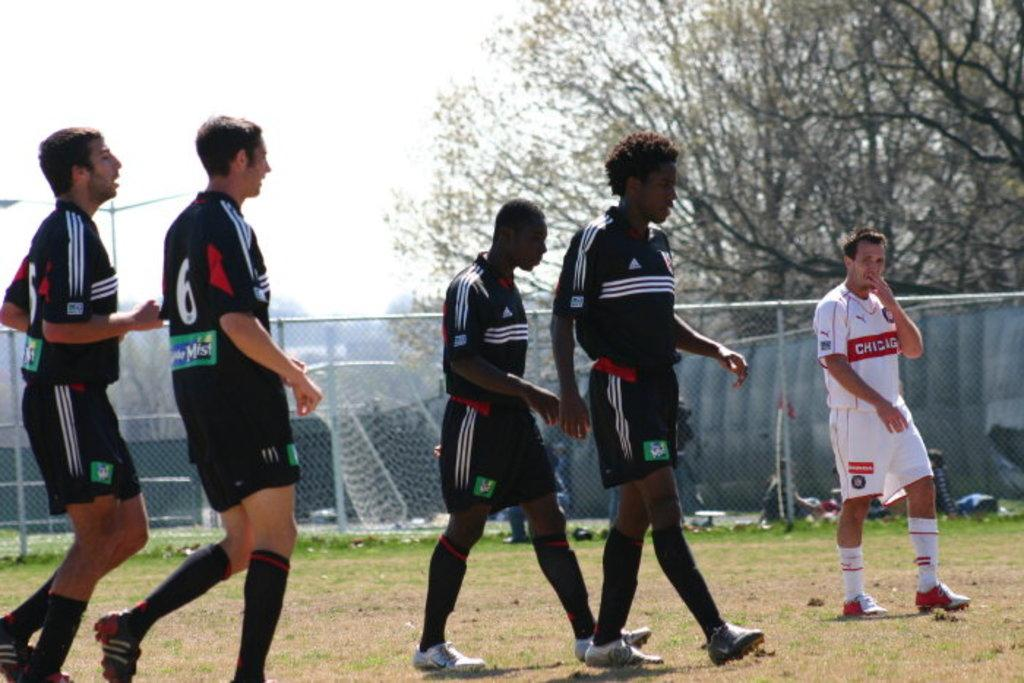<image>
Offer a succinct explanation of the picture presented. A soccer player has the number 6 on his jersey. 